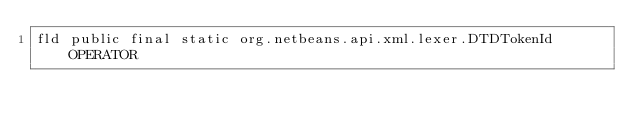<code> <loc_0><loc_0><loc_500><loc_500><_SML_>fld public final static org.netbeans.api.xml.lexer.DTDTokenId OPERATOR</code> 